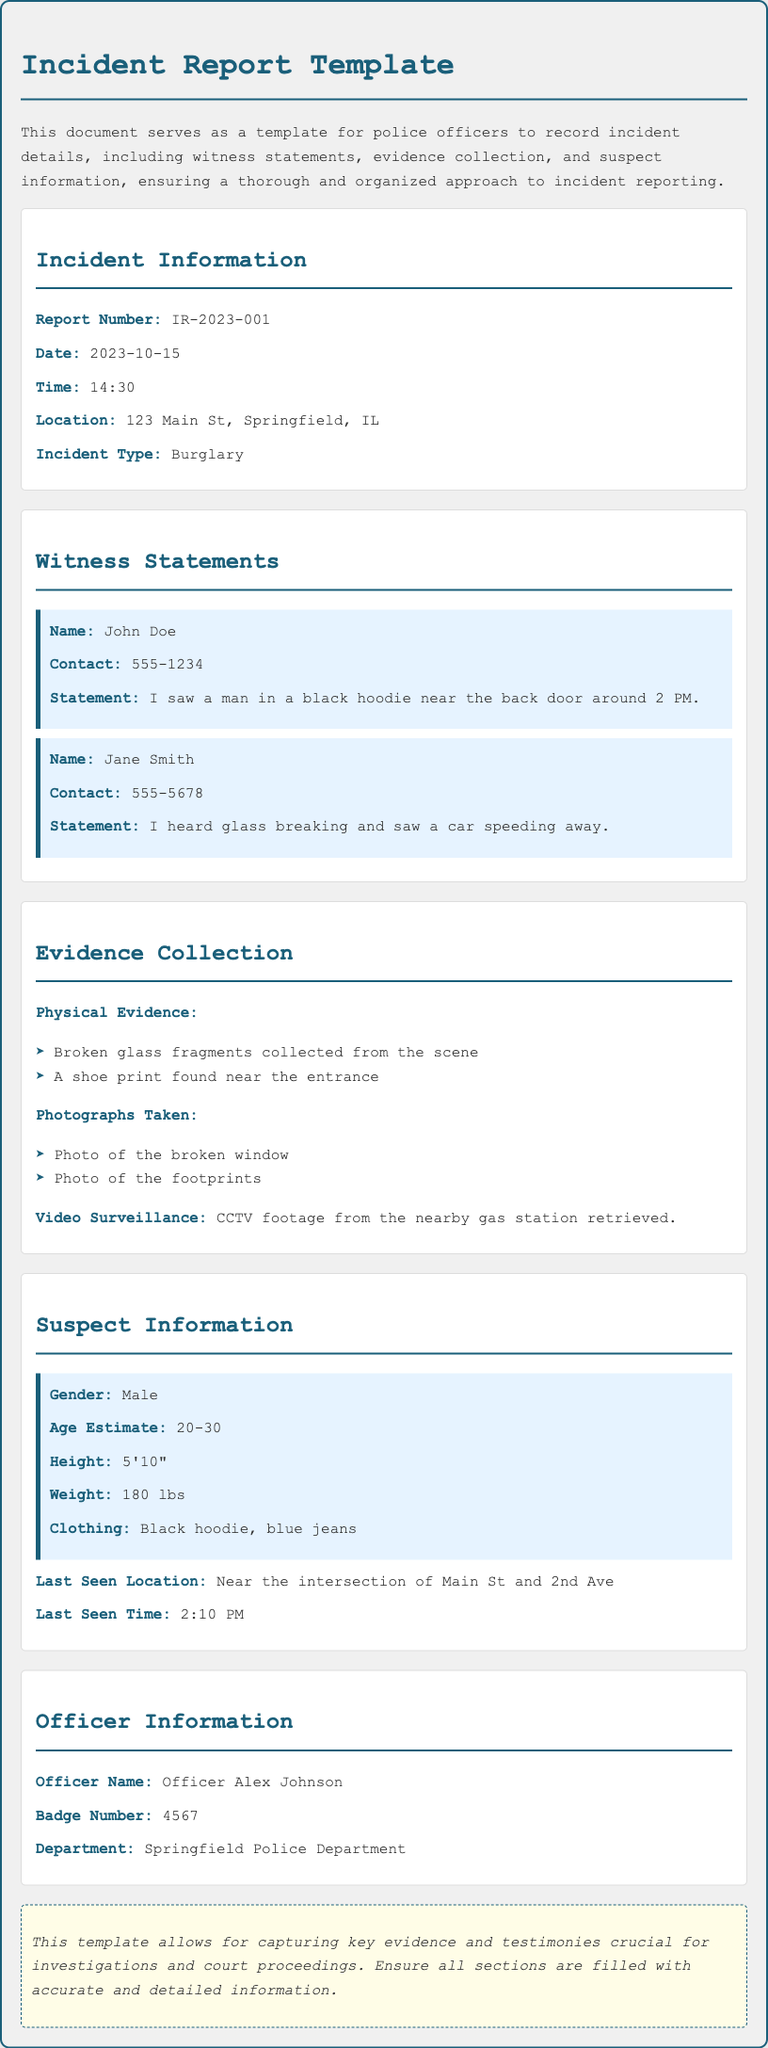What is the report number? The report number is stated in the Incident Information section of the document, which is IR-2023-001.
Answer: IR-2023-001 What is the incident type? The incident type is mentioned in the Incident Information section, which identifies it as Burglary.
Answer: Burglary Who is the first witness? The first witness's name is found in the Witness Statements section, which is John Doe.
Answer: John Doe What evidence was collected from the scene? The specific evidence mentioned in the Evidence Collection section includes broken glass fragments and a shoe print.
Answer: Broken glass fragments What time was the suspect last seen? The time when the suspect was last seen is provided in the Suspect Information section, which is 2:10 PM.
Answer: 2:10 PM How many witness statements are collected in this report? The number of witness statements in the report indicates there are two individuals providing their accounts.
Answer: Two What is the gender of the suspect? The suspect's gender is listed in the Suspect Information section as Male.
Answer: Male What is Officer Alex Johnson's badge number? Officer Alex Johnson's badge number is found in the Officer Information section, which is 4567.
Answer: 4567 What physical evidence includes photographs? The Evidence Collection section specifies that photographs were taken, including a photo of the broken window.
Answer: Photo of the broken window 